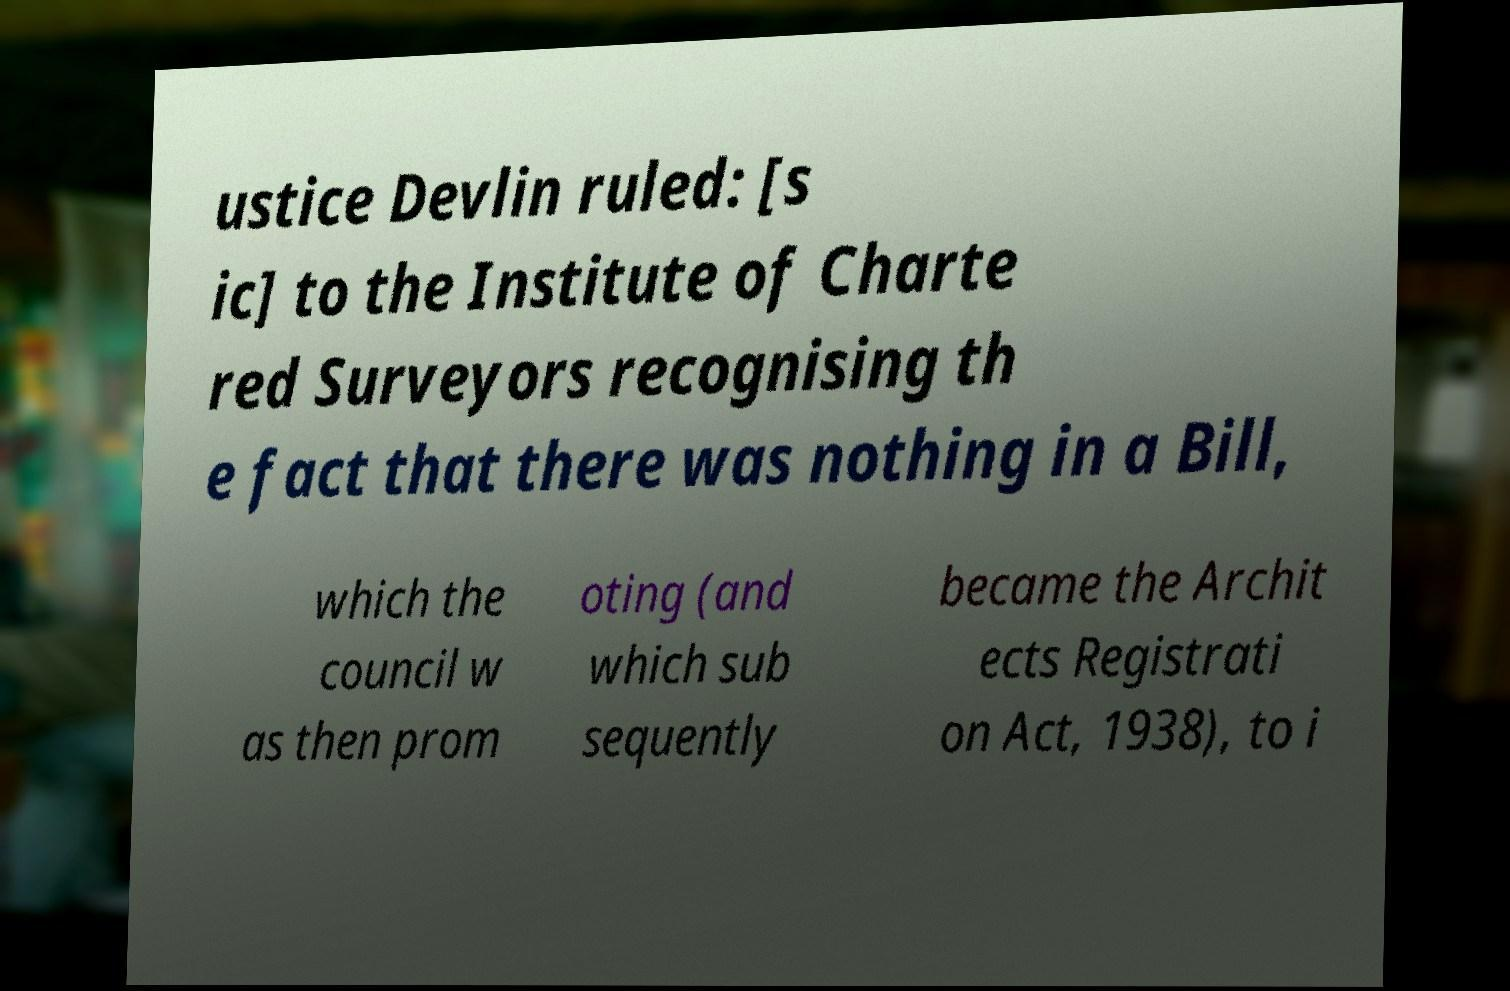There's text embedded in this image that I need extracted. Can you transcribe it verbatim? ustice Devlin ruled: [s ic] to the Institute of Charte red Surveyors recognising th e fact that there was nothing in a Bill, which the council w as then prom oting (and which sub sequently became the Archit ects Registrati on Act, 1938), to i 